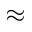<formula> <loc_0><loc_0><loc_500><loc_500>\approx</formula> 